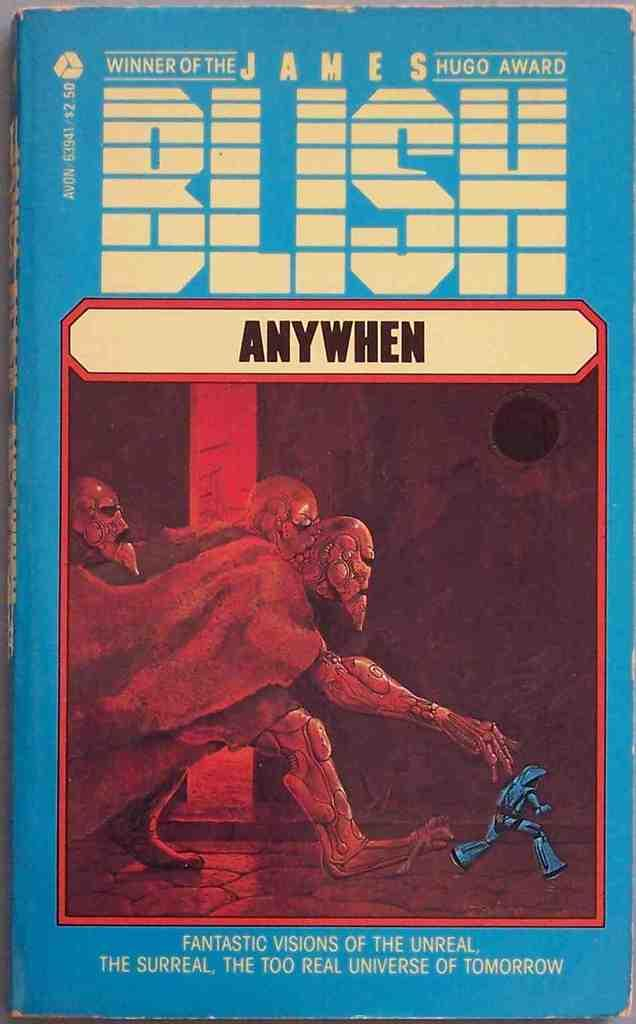<image>
Create a compact narrative representing the image presented. A James Blish novel called Anywhen sits on a table. 